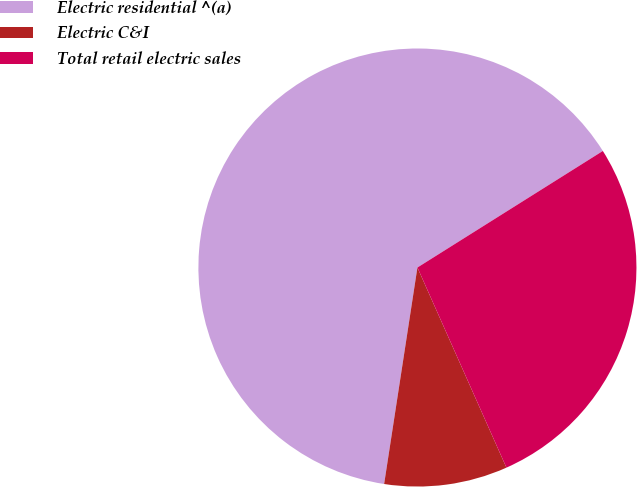Convert chart to OTSL. <chart><loc_0><loc_0><loc_500><loc_500><pie_chart><fcel>Electric residential ^(a)<fcel>Electric C&I<fcel>Total retail electric sales<nl><fcel>63.64%<fcel>9.09%<fcel>27.27%<nl></chart> 